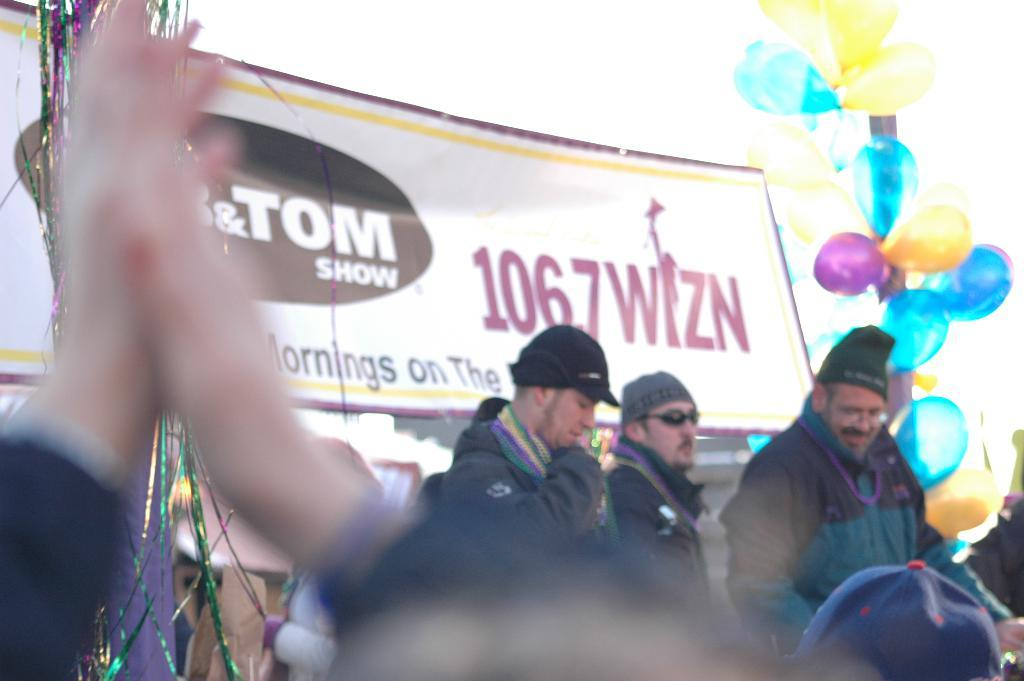What can be seen in the image regarding the people? There are people standing in the image. What are the people wearing on their heads? The people are wearing caps. What is attached to the iron pole in the image? There are balloons on an iron pole. What else can be seen hanging in the image? There are colorful sparkle wires hanging in the image. What type of suit is the mom wearing in the image? There is no mom or suit present in the image. How does the shock affect the people in the image? There is no shock present in the image, so it cannot affect the people. 